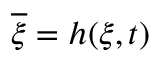<formula> <loc_0><loc_0><loc_500><loc_500>\overline { \xi } = h ( \xi , t )</formula> 